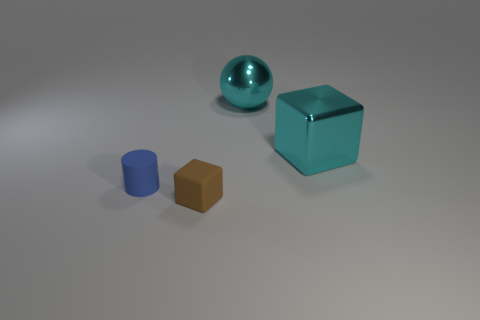What can you tell me about the lighting in this scene? The lighting in this scene seems to originate from the upper left corner, as indicated by the positioning of the shadows cast by the objects. It is a diffused light source, creating soft shadows and a calm ambiance.  Is there a specific mood or atmosphere that this image evokes? The image has a serene and minimalist aesthetic, evoking a sense of tranquility and order. The cool tones of the objects contribute to these impressions, along with the soft lighting. 